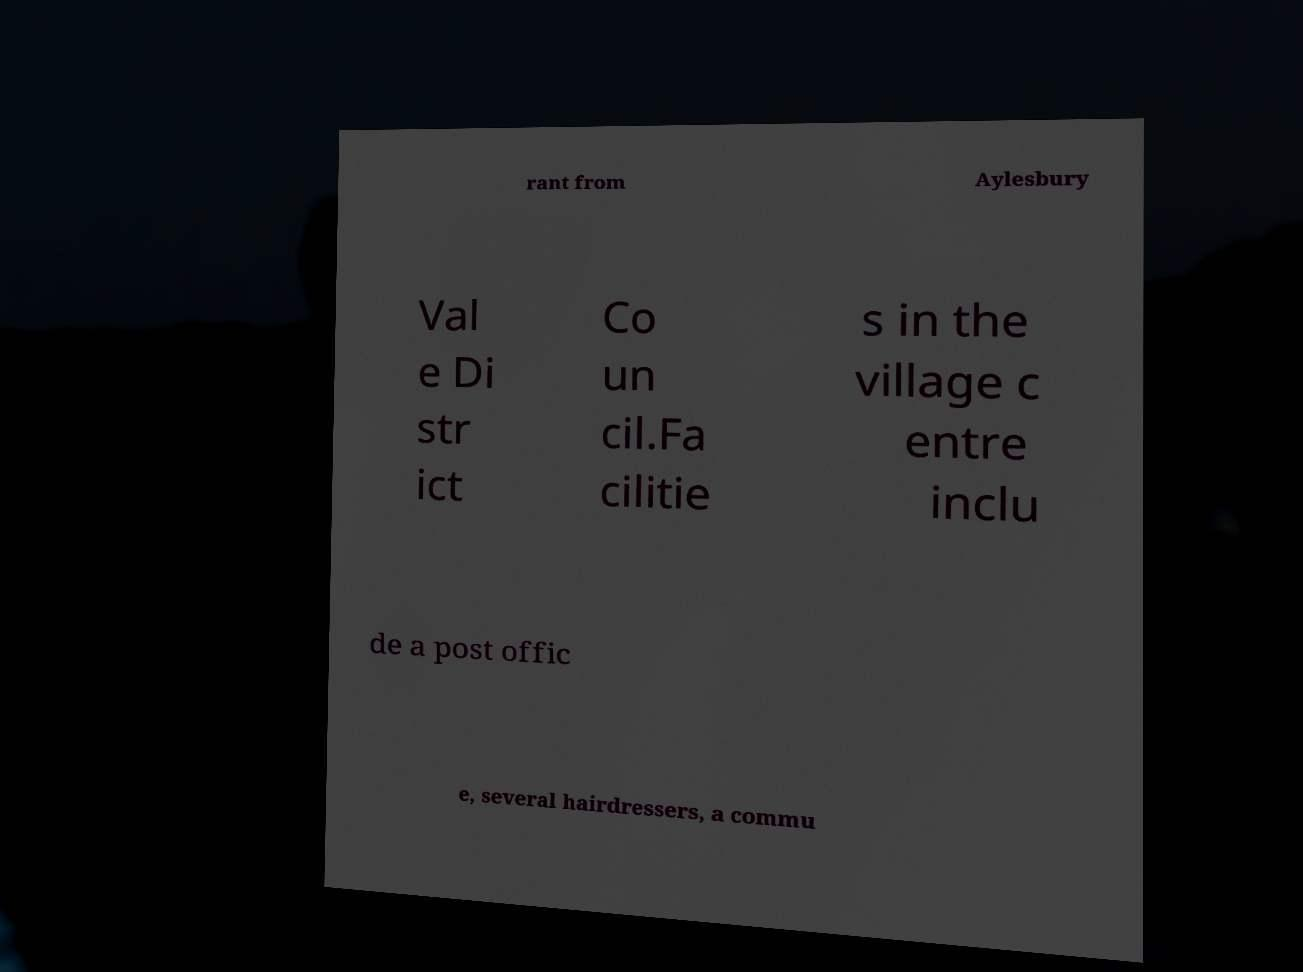What messages or text are displayed in this image? I need them in a readable, typed format. rant from Aylesbury Val e Di str ict Co un cil.Fa cilitie s in the village c entre inclu de a post offic e, several hairdressers, a commu 